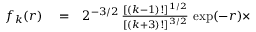Convert formula to latex. <formula><loc_0><loc_0><loc_500><loc_500>\begin{array} { r l r } { f _ { k } ( r ) } & = } & { 2 ^ { - 3 / 2 } \, \frac { [ ( k - 1 ) ! ] ^ { 1 / 2 } } { [ ( k + 3 ) ! ] ^ { 3 / 2 } } \, \exp ( - r ) \times } \end{array}</formula> 